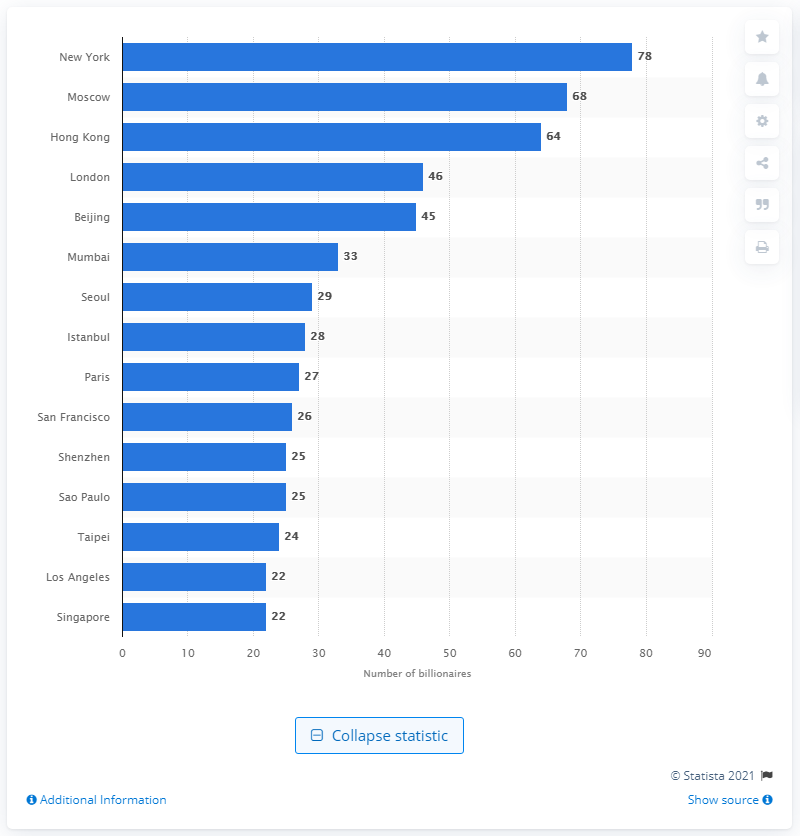Identify some key points in this picture. There were 78 billionaires who lived in New York in 2015. 